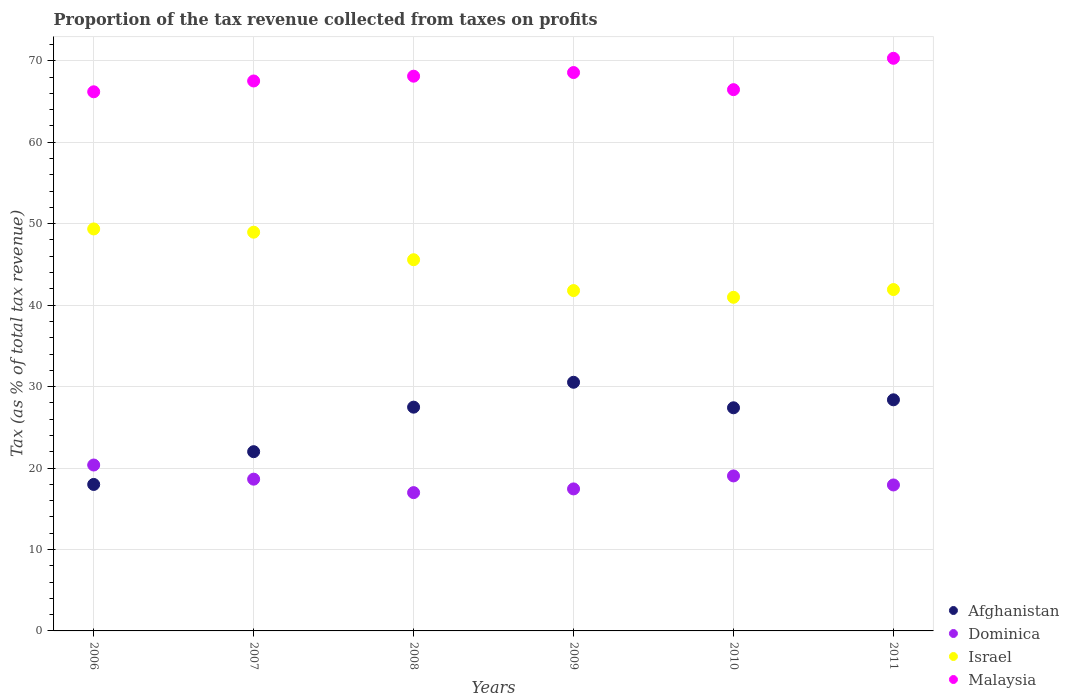How many different coloured dotlines are there?
Your answer should be very brief. 4. Is the number of dotlines equal to the number of legend labels?
Ensure brevity in your answer.  Yes. What is the proportion of the tax revenue collected in Dominica in 2007?
Your answer should be very brief. 18.63. Across all years, what is the maximum proportion of the tax revenue collected in Afghanistan?
Provide a short and direct response. 30.53. Across all years, what is the minimum proportion of the tax revenue collected in Afghanistan?
Offer a terse response. 17.98. In which year was the proportion of the tax revenue collected in Israel maximum?
Make the answer very short. 2006. In which year was the proportion of the tax revenue collected in Dominica minimum?
Make the answer very short. 2008. What is the total proportion of the tax revenue collected in Malaysia in the graph?
Provide a succinct answer. 407.17. What is the difference between the proportion of the tax revenue collected in Afghanistan in 2007 and that in 2008?
Keep it short and to the point. -5.47. What is the difference between the proportion of the tax revenue collected in Afghanistan in 2009 and the proportion of the tax revenue collected in Dominica in 2008?
Your response must be concise. 13.55. What is the average proportion of the tax revenue collected in Israel per year?
Offer a very short reply. 44.76. In the year 2008, what is the difference between the proportion of the tax revenue collected in Malaysia and proportion of the tax revenue collected in Israel?
Your answer should be very brief. 22.54. In how many years, is the proportion of the tax revenue collected in Afghanistan greater than 52 %?
Offer a very short reply. 0. What is the ratio of the proportion of the tax revenue collected in Afghanistan in 2008 to that in 2010?
Provide a short and direct response. 1. Is the proportion of the tax revenue collected in Afghanistan in 2006 less than that in 2010?
Keep it short and to the point. Yes. What is the difference between the highest and the second highest proportion of the tax revenue collected in Afghanistan?
Offer a terse response. 2.15. What is the difference between the highest and the lowest proportion of the tax revenue collected in Israel?
Your answer should be very brief. 8.39. In how many years, is the proportion of the tax revenue collected in Afghanistan greater than the average proportion of the tax revenue collected in Afghanistan taken over all years?
Offer a terse response. 4. Is the sum of the proportion of the tax revenue collected in Afghanistan in 2006 and 2010 greater than the maximum proportion of the tax revenue collected in Israel across all years?
Your response must be concise. No. Is it the case that in every year, the sum of the proportion of the tax revenue collected in Malaysia and proportion of the tax revenue collected in Afghanistan  is greater than the sum of proportion of the tax revenue collected in Dominica and proportion of the tax revenue collected in Israel?
Keep it short and to the point. No. Does the proportion of the tax revenue collected in Afghanistan monotonically increase over the years?
Give a very brief answer. No. Is the proportion of the tax revenue collected in Afghanistan strictly greater than the proportion of the tax revenue collected in Israel over the years?
Give a very brief answer. No. How many dotlines are there?
Make the answer very short. 4. Does the graph contain any zero values?
Make the answer very short. No. Where does the legend appear in the graph?
Your answer should be very brief. Bottom right. How many legend labels are there?
Offer a very short reply. 4. How are the legend labels stacked?
Ensure brevity in your answer.  Vertical. What is the title of the graph?
Ensure brevity in your answer.  Proportion of the tax revenue collected from taxes on profits. Does "South Asia" appear as one of the legend labels in the graph?
Your answer should be compact. No. What is the label or title of the Y-axis?
Your response must be concise. Tax (as % of total tax revenue). What is the Tax (as % of total tax revenue) of Afghanistan in 2006?
Ensure brevity in your answer.  17.98. What is the Tax (as % of total tax revenue) of Dominica in 2006?
Ensure brevity in your answer.  20.37. What is the Tax (as % of total tax revenue) of Israel in 2006?
Provide a short and direct response. 49.36. What is the Tax (as % of total tax revenue) of Malaysia in 2006?
Provide a short and direct response. 66.2. What is the Tax (as % of total tax revenue) in Afghanistan in 2007?
Provide a short and direct response. 22.01. What is the Tax (as % of total tax revenue) in Dominica in 2007?
Your response must be concise. 18.63. What is the Tax (as % of total tax revenue) in Israel in 2007?
Make the answer very short. 48.96. What is the Tax (as % of total tax revenue) in Malaysia in 2007?
Your response must be concise. 67.53. What is the Tax (as % of total tax revenue) in Afghanistan in 2008?
Provide a succinct answer. 27.48. What is the Tax (as % of total tax revenue) of Dominica in 2008?
Ensure brevity in your answer.  16.98. What is the Tax (as % of total tax revenue) of Israel in 2008?
Provide a succinct answer. 45.58. What is the Tax (as % of total tax revenue) in Malaysia in 2008?
Your response must be concise. 68.11. What is the Tax (as % of total tax revenue) of Afghanistan in 2009?
Your answer should be very brief. 30.53. What is the Tax (as % of total tax revenue) of Dominica in 2009?
Keep it short and to the point. 17.44. What is the Tax (as % of total tax revenue) in Israel in 2009?
Give a very brief answer. 41.79. What is the Tax (as % of total tax revenue) in Malaysia in 2009?
Give a very brief answer. 68.56. What is the Tax (as % of total tax revenue) in Afghanistan in 2010?
Provide a succinct answer. 27.4. What is the Tax (as % of total tax revenue) in Dominica in 2010?
Provide a short and direct response. 19.03. What is the Tax (as % of total tax revenue) of Israel in 2010?
Keep it short and to the point. 40.97. What is the Tax (as % of total tax revenue) in Malaysia in 2010?
Make the answer very short. 66.46. What is the Tax (as % of total tax revenue) of Afghanistan in 2011?
Make the answer very short. 28.38. What is the Tax (as % of total tax revenue) of Dominica in 2011?
Give a very brief answer. 17.92. What is the Tax (as % of total tax revenue) in Israel in 2011?
Give a very brief answer. 41.92. What is the Tax (as % of total tax revenue) of Malaysia in 2011?
Your answer should be compact. 70.31. Across all years, what is the maximum Tax (as % of total tax revenue) in Afghanistan?
Make the answer very short. 30.53. Across all years, what is the maximum Tax (as % of total tax revenue) of Dominica?
Ensure brevity in your answer.  20.37. Across all years, what is the maximum Tax (as % of total tax revenue) in Israel?
Your answer should be compact. 49.36. Across all years, what is the maximum Tax (as % of total tax revenue) in Malaysia?
Ensure brevity in your answer.  70.31. Across all years, what is the minimum Tax (as % of total tax revenue) in Afghanistan?
Provide a succinct answer. 17.98. Across all years, what is the minimum Tax (as % of total tax revenue) in Dominica?
Keep it short and to the point. 16.98. Across all years, what is the minimum Tax (as % of total tax revenue) in Israel?
Ensure brevity in your answer.  40.97. Across all years, what is the minimum Tax (as % of total tax revenue) of Malaysia?
Ensure brevity in your answer.  66.2. What is the total Tax (as % of total tax revenue) of Afghanistan in the graph?
Make the answer very short. 153.78. What is the total Tax (as % of total tax revenue) of Dominica in the graph?
Give a very brief answer. 110.37. What is the total Tax (as % of total tax revenue) of Israel in the graph?
Your response must be concise. 268.57. What is the total Tax (as % of total tax revenue) of Malaysia in the graph?
Ensure brevity in your answer.  407.17. What is the difference between the Tax (as % of total tax revenue) of Afghanistan in 2006 and that in 2007?
Your response must be concise. -4.02. What is the difference between the Tax (as % of total tax revenue) of Dominica in 2006 and that in 2007?
Your response must be concise. 1.74. What is the difference between the Tax (as % of total tax revenue) of Israel in 2006 and that in 2007?
Your answer should be very brief. 0.4. What is the difference between the Tax (as % of total tax revenue) of Malaysia in 2006 and that in 2007?
Provide a succinct answer. -1.33. What is the difference between the Tax (as % of total tax revenue) in Afghanistan in 2006 and that in 2008?
Provide a succinct answer. -9.49. What is the difference between the Tax (as % of total tax revenue) of Dominica in 2006 and that in 2008?
Offer a terse response. 3.39. What is the difference between the Tax (as % of total tax revenue) in Israel in 2006 and that in 2008?
Offer a very short reply. 3.78. What is the difference between the Tax (as % of total tax revenue) of Malaysia in 2006 and that in 2008?
Make the answer very short. -1.92. What is the difference between the Tax (as % of total tax revenue) in Afghanistan in 2006 and that in 2009?
Provide a short and direct response. -12.55. What is the difference between the Tax (as % of total tax revenue) in Dominica in 2006 and that in 2009?
Provide a succinct answer. 2.94. What is the difference between the Tax (as % of total tax revenue) of Israel in 2006 and that in 2009?
Your response must be concise. 7.57. What is the difference between the Tax (as % of total tax revenue) of Malaysia in 2006 and that in 2009?
Provide a succinct answer. -2.36. What is the difference between the Tax (as % of total tax revenue) of Afghanistan in 2006 and that in 2010?
Your answer should be very brief. -9.41. What is the difference between the Tax (as % of total tax revenue) in Dominica in 2006 and that in 2010?
Your response must be concise. 1.34. What is the difference between the Tax (as % of total tax revenue) of Israel in 2006 and that in 2010?
Your answer should be very brief. 8.39. What is the difference between the Tax (as % of total tax revenue) of Malaysia in 2006 and that in 2010?
Your answer should be compact. -0.26. What is the difference between the Tax (as % of total tax revenue) in Afghanistan in 2006 and that in 2011?
Provide a succinct answer. -10.39. What is the difference between the Tax (as % of total tax revenue) of Dominica in 2006 and that in 2011?
Your response must be concise. 2.45. What is the difference between the Tax (as % of total tax revenue) of Israel in 2006 and that in 2011?
Provide a short and direct response. 7.44. What is the difference between the Tax (as % of total tax revenue) of Malaysia in 2006 and that in 2011?
Provide a succinct answer. -4.11. What is the difference between the Tax (as % of total tax revenue) of Afghanistan in 2007 and that in 2008?
Your answer should be very brief. -5.47. What is the difference between the Tax (as % of total tax revenue) in Dominica in 2007 and that in 2008?
Offer a terse response. 1.65. What is the difference between the Tax (as % of total tax revenue) of Israel in 2007 and that in 2008?
Ensure brevity in your answer.  3.38. What is the difference between the Tax (as % of total tax revenue) of Malaysia in 2007 and that in 2008?
Provide a short and direct response. -0.59. What is the difference between the Tax (as % of total tax revenue) in Afghanistan in 2007 and that in 2009?
Ensure brevity in your answer.  -8.52. What is the difference between the Tax (as % of total tax revenue) in Dominica in 2007 and that in 2009?
Provide a short and direct response. 1.2. What is the difference between the Tax (as % of total tax revenue) in Israel in 2007 and that in 2009?
Your answer should be compact. 7.17. What is the difference between the Tax (as % of total tax revenue) in Malaysia in 2007 and that in 2009?
Offer a terse response. -1.04. What is the difference between the Tax (as % of total tax revenue) in Afghanistan in 2007 and that in 2010?
Make the answer very short. -5.39. What is the difference between the Tax (as % of total tax revenue) in Dominica in 2007 and that in 2010?
Offer a terse response. -0.4. What is the difference between the Tax (as % of total tax revenue) of Israel in 2007 and that in 2010?
Keep it short and to the point. 7.99. What is the difference between the Tax (as % of total tax revenue) of Malaysia in 2007 and that in 2010?
Your answer should be very brief. 1.07. What is the difference between the Tax (as % of total tax revenue) of Afghanistan in 2007 and that in 2011?
Offer a terse response. -6.37. What is the difference between the Tax (as % of total tax revenue) in Dominica in 2007 and that in 2011?
Give a very brief answer. 0.71. What is the difference between the Tax (as % of total tax revenue) in Israel in 2007 and that in 2011?
Your answer should be compact. 7.04. What is the difference between the Tax (as % of total tax revenue) in Malaysia in 2007 and that in 2011?
Provide a succinct answer. -2.79. What is the difference between the Tax (as % of total tax revenue) of Afghanistan in 2008 and that in 2009?
Offer a terse response. -3.06. What is the difference between the Tax (as % of total tax revenue) in Dominica in 2008 and that in 2009?
Your answer should be very brief. -0.45. What is the difference between the Tax (as % of total tax revenue) of Israel in 2008 and that in 2009?
Make the answer very short. 3.79. What is the difference between the Tax (as % of total tax revenue) of Malaysia in 2008 and that in 2009?
Offer a very short reply. -0.45. What is the difference between the Tax (as % of total tax revenue) in Afghanistan in 2008 and that in 2010?
Provide a succinct answer. 0.08. What is the difference between the Tax (as % of total tax revenue) of Dominica in 2008 and that in 2010?
Provide a short and direct response. -2.05. What is the difference between the Tax (as % of total tax revenue) in Israel in 2008 and that in 2010?
Offer a terse response. 4.61. What is the difference between the Tax (as % of total tax revenue) of Malaysia in 2008 and that in 2010?
Provide a succinct answer. 1.65. What is the difference between the Tax (as % of total tax revenue) in Afghanistan in 2008 and that in 2011?
Ensure brevity in your answer.  -0.9. What is the difference between the Tax (as % of total tax revenue) in Dominica in 2008 and that in 2011?
Your response must be concise. -0.94. What is the difference between the Tax (as % of total tax revenue) of Israel in 2008 and that in 2011?
Your response must be concise. 3.66. What is the difference between the Tax (as % of total tax revenue) in Malaysia in 2008 and that in 2011?
Give a very brief answer. -2.2. What is the difference between the Tax (as % of total tax revenue) of Afghanistan in 2009 and that in 2010?
Provide a succinct answer. 3.13. What is the difference between the Tax (as % of total tax revenue) in Dominica in 2009 and that in 2010?
Provide a succinct answer. -1.59. What is the difference between the Tax (as % of total tax revenue) in Israel in 2009 and that in 2010?
Keep it short and to the point. 0.82. What is the difference between the Tax (as % of total tax revenue) in Malaysia in 2009 and that in 2010?
Your answer should be compact. 2.1. What is the difference between the Tax (as % of total tax revenue) of Afghanistan in 2009 and that in 2011?
Your answer should be very brief. 2.15. What is the difference between the Tax (as % of total tax revenue) of Dominica in 2009 and that in 2011?
Your answer should be compact. -0.49. What is the difference between the Tax (as % of total tax revenue) in Israel in 2009 and that in 2011?
Your answer should be compact. -0.13. What is the difference between the Tax (as % of total tax revenue) in Malaysia in 2009 and that in 2011?
Make the answer very short. -1.75. What is the difference between the Tax (as % of total tax revenue) in Afghanistan in 2010 and that in 2011?
Offer a very short reply. -0.98. What is the difference between the Tax (as % of total tax revenue) of Dominica in 2010 and that in 2011?
Your answer should be compact. 1.11. What is the difference between the Tax (as % of total tax revenue) in Israel in 2010 and that in 2011?
Your answer should be compact. -0.95. What is the difference between the Tax (as % of total tax revenue) in Malaysia in 2010 and that in 2011?
Provide a succinct answer. -3.85. What is the difference between the Tax (as % of total tax revenue) of Afghanistan in 2006 and the Tax (as % of total tax revenue) of Dominica in 2007?
Give a very brief answer. -0.65. What is the difference between the Tax (as % of total tax revenue) in Afghanistan in 2006 and the Tax (as % of total tax revenue) in Israel in 2007?
Keep it short and to the point. -30.97. What is the difference between the Tax (as % of total tax revenue) of Afghanistan in 2006 and the Tax (as % of total tax revenue) of Malaysia in 2007?
Make the answer very short. -49.54. What is the difference between the Tax (as % of total tax revenue) of Dominica in 2006 and the Tax (as % of total tax revenue) of Israel in 2007?
Offer a very short reply. -28.59. What is the difference between the Tax (as % of total tax revenue) of Dominica in 2006 and the Tax (as % of total tax revenue) of Malaysia in 2007?
Provide a succinct answer. -47.15. What is the difference between the Tax (as % of total tax revenue) of Israel in 2006 and the Tax (as % of total tax revenue) of Malaysia in 2007?
Offer a very short reply. -18.17. What is the difference between the Tax (as % of total tax revenue) of Afghanistan in 2006 and the Tax (as % of total tax revenue) of Israel in 2008?
Ensure brevity in your answer.  -27.59. What is the difference between the Tax (as % of total tax revenue) of Afghanistan in 2006 and the Tax (as % of total tax revenue) of Malaysia in 2008?
Keep it short and to the point. -50.13. What is the difference between the Tax (as % of total tax revenue) in Dominica in 2006 and the Tax (as % of total tax revenue) in Israel in 2008?
Offer a very short reply. -25.21. What is the difference between the Tax (as % of total tax revenue) of Dominica in 2006 and the Tax (as % of total tax revenue) of Malaysia in 2008?
Provide a short and direct response. -47.74. What is the difference between the Tax (as % of total tax revenue) of Israel in 2006 and the Tax (as % of total tax revenue) of Malaysia in 2008?
Provide a succinct answer. -18.76. What is the difference between the Tax (as % of total tax revenue) in Afghanistan in 2006 and the Tax (as % of total tax revenue) in Dominica in 2009?
Ensure brevity in your answer.  0.55. What is the difference between the Tax (as % of total tax revenue) in Afghanistan in 2006 and the Tax (as % of total tax revenue) in Israel in 2009?
Make the answer very short. -23.81. What is the difference between the Tax (as % of total tax revenue) in Afghanistan in 2006 and the Tax (as % of total tax revenue) in Malaysia in 2009?
Your answer should be very brief. -50.58. What is the difference between the Tax (as % of total tax revenue) in Dominica in 2006 and the Tax (as % of total tax revenue) in Israel in 2009?
Your answer should be compact. -21.42. What is the difference between the Tax (as % of total tax revenue) of Dominica in 2006 and the Tax (as % of total tax revenue) of Malaysia in 2009?
Give a very brief answer. -48.19. What is the difference between the Tax (as % of total tax revenue) of Israel in 2006 and the Tax (as % of total tax revenue) of Malaysia in 2009?
Give a very brief answer. -19.2. What is the difference between the Tax (as % of total tax revenue) of Afghanistan in 2006 and the Tax (as % of total tax revenue) of Dominica in 2010?
Your response must be concise. -1.05. What is the difference between the Tax (as % of total tax revenue) in Afghanistan in 2006 and the Tax (as % of total tax revenue) in Israel in 2010?
Your answer should be very brief. -22.98. What is the difference between the Tax (as % of total tax revenue) in Afghanistan in 2006 and the Tax (as % of total tax revenue) in Malaysia in 2010?
Make the answer very short. -48.48. What is the difference between the Tax (as % of total tax revenue) of Dominica in 2006 and the Tax (as % of total tax revenue) of Israel in 2010?
Ensure brevity in your answer.  -20.59. What is the difference between the Tax (as % of total tax revenue) in Dominica in 2006 and the Tax (as % of total tax revenue) in Malaysia in 2010?
Keep it short and to the point. -46.09. What is the difference between the Tax (as % of total tax revenue) of Israel in 2006 and the Tax (as % of total tax revenue) of Malaysia in 2010?
Your response must be concise. -17.1. What is the difference between the Tax (as % of total tax revenue) of Afghanistan in 2006 and the Tax (as % of total tax revenue) of Dominica in 2011?
Your response must be concise. 0.06. What is the difference between the Tax (as % of total tax revenue) of Afghanistan in 2006 and the Tax (as % of total tax revenue) of Israel in 2011?
Provide a short and direct response. -23.93. What is the difference between the Tax (as % of total tax revenue) in Afghanistan in 2006 and the Tax (as % of total tax revenue) in Malaysia in 2011?
Keep it short and to the point. -52.33. What is the difference between the Tax (as % of total tax revenue) of Dominica in 2006 and the Tax (as % of total tax revenue) of Israel in 2011?
Ensure brevity in your answer.  -21.55. What is the difference between the Tax (as % of total tax revenue) of Dominica in 2006 and the Tax (as % of total tax revenue) of Malaysia in 2011?
Your answer should be compact. -49.94. What is the difference between the Tax (as % of total tax revenue) in Israel in 2006 and the Tax (as % of total tax revenue) in Malaysia in 2011?
Provide a succinct answer. -20.95. What is the difference between the Tax (as % of total tax revenue) of Afghanistan in 2007 and the Tax (as % of total tax revenue) of Dominica in 2008?
Give a very brief answer. 5.03. What is the difference between the Tax (as % of total tax revenue) in Afghanistan in 2007 and the Tax (as % of total tax revenue) in Israel in 2008?
Your answer should be very brief. -23.57. What is the difference between the Tax (as % of total tax revenue) of Afghanistan in 2007 and the Tax (as % of total tax revenue) of Malaysia in 2008?
Your response must be concise. -46.1. What is the difference between the Tax (as % of total tax revenue) of Dominica in 2007 and the Tax (as % of total tax revenue) of Israel in 2008?
Provide a short and direct response. -26.94. What is the difference between the Tax (as % of total tax revenue) in Dominica in 2007 and the Tax (as % of total tax revenue) in Malaysia in 2008?
Offer a very short reply. -49.48. What is the difference between the Tax (as % of total tax revenue) of Israel in 2007 and the Tax (as % of total tax revenue) of Malaysia in 2008?
Provide a succinct answer. -19.16. What is the difference between the Tax (as % of total tax revenue) in Afghanistan in 2007 and the Tax (as % of total tax revenue) in Dominica in 2009?
Give a very brief answer. 4.57. What is the difference between the Tax (as % of total tax revenue) in Afghanistan in 2007 and the Tax (as % of total tax revenue) in Israel in 2009?
Keep it short and to the point. -19.78. What is the difference between the Tax (as % of total tax revenue) of Afghanistan in 2007 and the Tax (as % of total tax revenue) of Malaysia in 2009?
Make the answer very short. -46.55. What is the difference between the Tax (as % of total tax revenue) of Dominica in 2007 and the Tax (as % of total tax revenue) of Israel in 2009?
Provide a short and direct response. -23.16. What is the difference between the Tax (as % of total tax revenue) in Dominica in 2007 and the Tax (as % of total tax revenue) in Malaysia in 2009?
Give a very brief answer. -49.93. What is the difference between the Tax (as % of total tax revenue) of Israel in 2007 and the Tax (as % of total tax revenue) of Malaysia in 2009?
Give a very brief answer. -19.6. What is the difference between the Tax (as % of total tax revenue) in Afghanistan in 2007 and the Tax (as % of total tax revenue) in Dominica in 2010?
Ensure brevity in your answer.  2.98. What is the difference between the Tax (as % of total tax revenue) of Afghanistan in 2007 and the Tax (as % of total tax revenue) of Israel in 2010?
Give a very brief answer. -18.96. What is the difference between the Tax (as % of total tax revenue) in Afghanistan in 2007 and the Tax (as % of total tax revenue) in Malaysia in 2010?
Provide a short and direct response. -44.45. What is the difference between the Tax (as % of total tax revenue) in Dominica in 2007 and the Tax (as % of total tax revenue) in Israel in 2010?
Ensure brevity in your answer.  -22.33. What is the difference between the Tax (as % of total tax revenue) in Dominica in 2007 and the Tax (as % of total tax revenue) in Malaysia in 2010?
Your answer should be compact. -47.83. What is the difference between the Tax (as % of total tax revenue) in Israel in 2007 and the Tax (as % of total tax revenue) in Malaysia in 2010?
Your response must be concise. -17.5. What is the difference between the Tax (as % of total tax revenue) of Afghanistan in 2007 and the Tax (as % of total tax revenue) of Dominica in 2011?
Provide a succinct answer. 4.09. What is the difference between the Tax (as % of total tax revenue) of Afghanistan in 2007 and the Tax (as % of total tax revenue) of Israel in 2011?
Offer a very short reply. -19.91. What is the difference between the Tax (as % of total tax revenue) in Afghanistan in 2007 and the Tax (as % of total tax revenue) in Malaysia in 2011?
Offer a terse response. -48.3. What is the difference between the Tax (as % of total tax revenue) in Dominica in 2007 and the Tax (as % of total tax revenue) in Israel in 2011?
Provide a short and direct response. -23.28. What is the difference between the Tax (as % of total tax revenue) of Dominica in 2007 and the Tax (as % of total tax revenue) of Malaysia in 2011?
Make the answer very short. -51.68. What is the difference between the Tax (as % of total tax revenue) of Israel in 2007 and the Tax (as % of total tax revenue) of Malaysia in 2011?
Offer a very short reply. -21.35. What is the difference between the Tax (as % of total tax revenue) of Afghanistan in 2008 and the Tax (as % of total tax revenue) of Dominica in 2009?
Your response must be concise. 10.04. What is the difference between the Tax (as % of total tax revenue) in Afghanistan in 2008 and the Tax (as % of total tax revenue) in Israel in 2009?
Give a very brief answer. -14.32. What is the difference between the Tax (as % of total tax revenue) of Afghanistan in 2008 and the Tax (as % of total tax revenue) of Malaysia in 2009?
Keep it short and to the point. -41.09. What is the difference between the Tax (as % of total tax revenue) of Dominica in 2008 and the Tax (as % of total tax revenue) of Israel in 2009?
Your answer should be very brief. -24.81. What is the difference between the Tax (as % of total tax revenue) in Dominica in 2008 and the Tax (as % of total tax revenue) in Malaysia in 2009?
Your answer should be very brief. -51.58. What is the difference between the Tax (as % of total tax revenue) in Israel in 2008 and the Tax (as % of total tax revenue) in Malaysia in 2009?
Your response must be concise. -22.98. What is the difference between the Tax (as % of total tax revenue) in Afghanistan in 2008 and the Tax (as % of total tax revenue) in Dominica in 2010?
Ensure brevity in your answer.  8.44. What is the difference between the Tax (as % of total tax revenue) of Afghanistan in 2008 and the Tax (as % of total tax revenue) of Israel in 2010?
Make the answer very short. -13.49. What is the difference between the Tax (as % of total tax revenue) of Afghanistan in 2008 and the Tax (as % of total tax revenue) of Malaysia in 2010?
Provide a succinct answer. -38.98. What is the difference between the Tax (as % of total tax revenue) of Dominica in 2008 and the Tax (as % of total tax revenue) of Israel in 2010?
Give a very brief answer. -23.98. What is the difference between the Tax (as % of total tax revenue) in Dominica in 2008 and the Tax (as % of total tax revenue) in Malaysia in 2010?
Keep it short and to the point. -49.48. What is the difference between the Tax (as % of total tax revenue) of Israel in 2008 and the Tax (as % of total tax revenue) of Malaysia in 2010?
Your answer should be very brief. -20.88. What is the difference between the Tax (as % of total tax revenue) in Afghanistan in 2008 and the Tax (as % of total tax revenue) in Dominica in 2011?
Make the answer very short. 9.55. What is the difference between the Tax (as % of total tax revenue) of Afghanistan in 2008 and the Tax (as % of total tax revenue) of Israel in 2011?
Provide a short and direct response. -14.44. What is the difference between the Tax (as % of total tax revenue) of Afghanistan in 2008 and the Tax (as % of total tax revenue) of Malaysia in 2011?
Provide a succinct answer. -42.84. What is the difference between the Tax (as % of total tax revenue) in Dominica in 2008 and the Tax (as % of total tax revenue) in Israel in 2011?
Offer a very short reply. -24.94. What is the difference between the Tax (as % of total tax revenue) of Dominica in 2008 and the Tax (as % of total tax revenue) of Malaysia in 2011?
Keep it short and to the point. -53.33. What is the difference between the Tax (as % of total tax revenue) in Israel in 2008 and the Tax (as % of total tax revenue) in Malaysia in 2011?
Provide a short and direct response. -24.73. What is the difference between the Tax (as % of total tax revenue) of Afghanistan in 2009 and the Tax (as % of total tax revenue) of Dominica in 2010?
Offer a very short reply. 11.5. What is the difference between the Tax (as % of total tax revenue) of Afghanistan in 2009 and the Tax (as % of total tax revenue) of Israel in 2010?
Provide a short and direct response. -10.43. What is the difference between the Tax (as % of total tax revenue) in Afghanistan in 2009 and the Tax (as % of total tax revenue) in Malaysia in 2010?
Provide a succinct answer. -35.93. What is the difference between the Tax (as % of total tax revenue) in Dominica in 2009 and the Tax (as % of total tax revenue) in Israel in 2010?
Your answer should be very brief. -23.53. What is the difference between the Tax (as % of total tax revenue) of Dominica in 2009 and the Tax (as % of total tax revenue) of Malaysia in 2010?
Give a very brief answer. -49.02. What is the difference between the Tax (as % of total tax revenue) in Israel in 2009 and the Tax (as % of total tax revenue) in Malaysia in 2010?
Give a very brief answer. -24.67. What is the difference between the Tax (as % of total tax revenue) of Afghanistan in 2009 and the Tax (as % of total tax revenue) of Dominica in 2011?
Make the answer very short. 12.61. What is the difference between the Tax (as % of total tax revenue) of Afghanistan in 2009 and the Tax (as % of total tax revenue) of Israel in 2011?
Give a very brief answer. -11.39. What is the difference between the Tax (as % of total tax revenue) in Afghanistan in 2009 and the Tax (as % of total tax revenue) in Malaysia in 2011?
Your answer should be very brief. -39.78. What is the difference between the Tax (as % of total tax revenue) in Dominica in 2009 and the Tax (as % of total tax revenue) in Israel in 2011?
Ensure brevity in your answer.  -24.48. What is the difference between the Tax (as % of total tax revenue) in Dominica in 2009 and the Tax (as % of total tax revenue) in Malaysia in 2011?
Give a very brief answer. -52.87. What is the difference between the Tax (as % of total tax revenue) in Israel in 2009 and the Tax (as % of total tax revenue) in Malaysia in 2011?
Your answer should be very brief. -28.52. What is the difference between the Tax (as % of total tax revenue) in Afghanistan in 2010 and the Tax (as % of total tax revenue) in Dominica in 2011?
Your response must be concise. 9.48. What is the difference between the Tax (as % of total tax revenue) of Afghanistan in 2010 and the Tax (as % of total tax revenue) of Israel in 2011?
Offer a terse response. -14.52. What is the difference between the Tax (as % of total tax revenue) in Afghanistan in 2010 and the Tax (as % of total tax revenue) in Malaysia in 2011?
Offer a very short reply. -42.91. What is the difference between the Tax (as % of total tax revenue) in Dominica in 2010 and the Tax (as % of total tax revenue) in Israel in 2011?
Your response must be concise. -22.89. What is the difference between the Tax (as % of total tax revenue) of Dominica in 2010 and the Tax (as % of total tax revenue) of Malaysia in 2011?
Your response must be concise. -51.28. What is the difference between the Tax (as % of total tax revenue) in Israel in 2010 and the Tax (as % of total tax revenue) in Malaysia in 2011?
Give a very brief answer. -29.35. What is the average Tax (as % of total tax revenue) of Afghanistan per year?
Give a very brief answer. 25.63. What is the average Tax (as % of total tax revenue) in Dominica per year?
Ensure brevity in your answer.  18.4. What is the average Tax (as % of total tax revenue) of Israel per year?
Ensure brevity in your answer.  44.76. What is the average Tax (as % of total tax revenue) of Malaysia per year?
Your answer should be very brief. 67.86. In the year 2006, what is the difference between the Tax (as % of total tax revenue) in Afghanistan and Tax (as % of total tax revenue) in Dominica?
Your answer should be very brief. -2.39. In the year 2006, what is the difference between the Tax (as % of total tax revenue) of Afghanistan and Tax (as % of total tax revenue) of Israel?
Your response must be concise. -31.37. In the year 2006, what is the difference between the Tax (as % of total tax revenue) in Afghanistan and Tax (as % of total tax revenue) in Malaysia?
Offer a very short reply. -48.21. In the year 2006, what is the difference between the Tax (as % of total tax revenue) of Dominica and Tax (as % of total tax revenue) of Israel?
Give a very brief answer. -28.99. In the year 2006, what is the difference between the Tax (as % of total tax revenue) of Dominica and Tax (as % of total tax revenue) of Malaysia?
Keep it short and to the point. -45.83. In the year 2006, what is the difference between the Tax (as % of total tax revenue) in Israel and Tax (as % of total tax revenue) in Malaysia?
Your answer should be compact. -16.84. In the year 2007, what is the difference between the Tax (as % of total tax revenue) of Afghanistan and Tax (as % of total tax revenue) of Dominica?
Offer a very short reply. 3.37. In the year 2007, what is the difference between the Tax (as % of total tax revenue) of Afghanistan and Tax (as % of total tax revenue) of Israel?
Your response must be concise. -26.95. In the year 2007, what is the difference between the Tax (as % of total tax revenue) of Afghanistan and Tax (as % of total tax revenue) of Malaysia?
Keep it short and to the point. -45.52. In the year 2007, what is the difference between the Tax (as % of total tax revenue) of Dominica and Tax (as % of total tax revenue) of Israel?
Your answer should be compact. -30.32. In the year 2007, what is the difference between the Tax (as % of total tax revenue) in Dominica and Tax (as % of total tax revenue) in Malaysia?
Offer a very short reply. -48.89. In the year 2007, what is the difference between the Tax (as % of total tax revenue) of Israel and Tax (as % of total tax revenue) of Malaysia?
Your answer should be very brief. -18.57. In the year 2008, what is the difference between the Tax (as % of total tax revenue) in Afghanistan and Tax (as % of total tax revenue) in Dominica?
Make the answer very short. 10.49. In the year 2008, what is the difference between the Tax (as % of total tax revenue) in Afghanistan and Tax (as % of total tax revenue) in Israel?
Provide a short and direct response. -18.1. In the year 2008, what is the difference between the Tax (as % of total tax revenue) of Afghanistan and Tax (as % of total tax revenue) of Malaysia?
Provide a succinct answer. -40.64. In the year 2008, what is the difference between the Tax (as % of total tax revenue) in Dominica and Tax (as % of total tax revenue) in Israel?
Offer a terse response. -28.6. In the year 2008, what is the difference between the Tax (as % of total tax revenue) of Dominica and Tax (as % of total tax revenue) of Malaysia?
Keep it short and to the point. -51.13. In the year 2008, what is the difference between the Tax (as % of total tax revenue) of Israel and Tax (as % of total tax revenue) of Malaysia?
Provide a succinct answer. -22.54. In the year 2009, what is the difference between the Tax (as % of total tax revenue) in Afghanistan and Tax (as % of total tax revenue) in Dominica?
Your answer should be very brief. 13.1. In the year 2009, what is the difference between the Tax (as % of total tax revenue) of Afghanistan and Tax (as % of total tax revenue) of Israel?
Your response must be concise. -11.26. In the year 2009, what is the difference between the Tax (as % of total tax revenue) of Afghanistan and Tax (as % of total tax revenue) of Malaysia?
Your response must be concise. -38.03. In the year 2009, what is the difference between the Tax (as % of total tax revenue) in Dominica and Tax (as % of total tax revenue) in Israel?
Provide a succinct answer. -24.35. In the year 2009, what is the difference between the Tax (as % of total tax revenue) of Dominica and Tax (as % of total tax revenue) of Malaysia?
Provide a short and direct response. -51.13. In the year 2009, what is the difference between the Tax (as % of total tax revenue) of Israel and Tax (as % of total tax revenue) of Malaysia?
Provide a succinct answer. -26.77. In the year 2010, what is the difference between the Tax (as % of total tax revenue) in Afghanistan and Tax (as % of total tax revenue) in Dominica?
Keep it short and to the point. 8.37. In the year 2010, what is the difference between the Tax (as % of total tax revenue) in Afghanistan and Tax (as % of total tax revenue) in Israel?
Keep it short and to the point. -13.57. In the year 2010, what is the difference between the Tax (as % of total tax revenue) in Afghanistan and Tax (as % of total tax revenue) in Malaysia?
Make the answer very short. -39.06. In the year 2010, what is the difference between the Tax (as % of total tax revenue) of Dominica and Tax (as % of total tax revenue) of Israel?
Your response must be concise. -21.94. In the year 2010, what is the difference between the Tax (as % of total tax revenue) in Dominica and Tax (as % of total tax revenue) in Malaysia?
Provide a succinct answer. -47.43. In the year 2010, what is the difference between the Tax (as % of total tax revenue) of Israel and Tax (as % of total tax revenue) of Malaysia?
Your response must be concise. -25.49. In the year 2011, what is the difference between the Tax (as % of total tax revenue) in Afghanistan and Tax (as % of total tax revenue) in Dominica?
Provide a succinct answer. 10.46. In the year 2011, what is the difference between the Tax (as % of total tax revenue) of Afghanistan and Tax (as % of total tax revenue) of Israel?
Ensure brevity in your answer.  -13.54. In the year 2011, what is the difference between the Tax (as % of total tax revenue) in Afghanistan and Tax (as % of total tax revenue) in Malaysia?
Your answer should be compact. -41.93. In the year 2011, what is the difference between the Tax (as % of total tax revenue) of Dominica and Tax (as % of total tax revenue) of Israel?
Your answer should be very brief. -23.99. In the year 2011, what is the difference between the Tax (as % of total tax revenue) of Dominica and Tax (as % of total tax revenue) of Malaysia?
Ensure brevity in your answer.  -52.39. In the year 2011, what is the difference between the Tax (as % of total tax revenue) of Israel and Tax (as % of total tax revenue) of Malaysia?
Offer a very short reply. -28.39. What is the ratio of the Tax (as % of total tax revenue) in Afghanistan in 2006 to that in 2007?
Provide a short and direct response. 0.82. What is the ratio of the Tax (as % of total tax revenue) in Dominica in 2006 to that in 2007?
Provide a succinct answer. 1.09. What is the ratio of the Tax (as % of total tax revenue) of Israel in 2006 to that in 2007?
Provide a short and direct response. 1.01. What is the ratio of the Tax (as % of total tax revenue) of Malaysia in 2006 to that in 2007?
Your answer should be compact. 0.98. What is the ratio of the Tax (as % of total tax revenue) in Afghanistan in 2006 to that in 2008?
Provide a succinct answer. 0.65. What is the ratio of the Tax (as % of total tax revenue) in Dominica in 2006 to that in 2008?
Offer a very short reply. 1.2. What is the ratio of the Tax (as % of total tax revenue) in Israel in 2006 to that in 2008?
Give a very brief answer. 1.08. What is the ratio of the Tax (as % of total tax revenue) in Malaysia in 2006 to that in 2008?
Offer a terse response. 0.97. What is the ratio of the Tax (as % of total tax revenue) of Afghanistan in 2006 to that in 2009?
Offer a terse response. 0.59. What is the ratio of the Tax (as % of total tax revenue) of Dominica in 2006 to that in 2009?
Your answer should be very brief. 1.17. What is the ratio of the Tax (as % of total tax revenue) of Israel in 2006 to that in 2009?
Your answer should be compact. 1.18. What is the ratio of the Tax (as % of total tax revenue) of Malaysia in 2006 to that in 2009?
Your response must be concise. 0.97. What is the ratio of the Tax (as % of total tax revenue) of Afghanistan in 2006 to that in 2010?
Keep it short and to the point. 0.66. What is the ratio of the Tax (as % of total tax revenue) of Dominica in 2006 to that in 2010?
Your answer should be very brief. 1.07. What is the ratio of the Tax (as % of total tax revenue) in Israel in 2006 to that in 2010?
Provide a succinct answer. 1.2. What is the ratio of the Tax (as % of total tax revenue) in Malaysia in 2006 to that in 2010?
Provide a short and direct response. 1. What is the ratio of the Tax (as % of total tax revenue) in Afghanistan in 2006 to that in 2011?
Offer a very short reply. 0.63. What is the ratio of the Tax (as % of total tax revenue) of Dominica in 2006 to that in 2011?
Ensure brevity in your answer.  1.14. What is the ratio of the Tax (as % of total tax revenue) in Israel in 2006 to that in 2011?
Your answer should be very brief. 1.18. What is the ratio of the Tax (as % of total tax revenue) of Malaysia in 2006 to that in 2011?
Make the answer very short. 0.94. What is the ratio of the Tax (as % of total tax revenue) in Afghanistan in 2007 to that in 2008?
Provide a short and direct response. 0.8. What is the ratio of the Tax (as % of total tax revenue) in Dominica in 2007 to that in 2008?
Provide a succinct answer. 1.1. What is the ratio of the Tax (as % of total tax revenue) in Israel in 2007 to that in 2008?
Your answer should be very brief. 1.07. What is the ratio of the Tax (as % of total tax revenue) in Malaysia in 2007 to that in 2008?
Offer a very short reply. 0.99. What is the ratio of the Tax (as % of total tax revenue) of Afghanistan in 2007 to that in 2009?
Ensure brevity in your answer.  0.72. What is the ratio of the Tax (as % of total tax revenue) of Dominica in 2007 to that in 2009?
Provide a short and direct response. 1.07. What is the ratio of the Tax (as % of total tax revenue) of Israel in 2007 to that in 2009?
Provide a succinct answer. 1.17. What is the ratio of the Tax (as % of total tax revenue) of Malaysia in 2007 to that in 2009?
Offer a terse response. 0.98. What is the ratio of the Tax (as % of total tax revenue) in Afghanistan in 2007 to that in 2010?
Provide a succinct answer. 0.8. What is the ratio of the Tax (as % of total tax revenue) of Dominica in 2007 to that in 2010?
Give a very brief answer. 0.98. What is the ratio of the Tax (as % of total tax revenue) of Israel in 2007 to that in 2010?
Provide a succinct answer. 1.2. What is the ratio of the Tax (as % of total tax revenue) of Afghanistan in 2007 to that in 2011?
Your response must be concise. 0.78. What is the ratio of the Tax (as % of total tax revenue) of Dominica in 2007 to that in 2011?
Make the answer very short. 1.04. What is the ratio of the Tax (as % of total tax revenue) in Israel in 2007 to that in 2011?
Your response must be concise. 1.17. What is the ratio of the Tax (as % of total tax revenue) in Malaysia in 2007 to that in 2011?
Your response must be concise. 0.96. What is the ratio of the Tax (as % of total tax revenue) of Afghanistan in 2008 to that in 2009?
Provide a short and direct response. 0.9. What is the ratio of the Tax (as % of total tax revenue) of Dominica in 2008 to that in 2009?
Give a very brief answer. 0.97. What is the ratio of the Tax (as % of total tax revenue) of Israel in 2008 to that in 2009?
Ensure brevity in your answer.  1.09. What is the ratio of the Tax (as % of total tax revenue) in Afghanistan in 2008 to that in 2010?
Offer a very short reply. 1. What is the ratio of the Tax (as % of total tax revenue) of Dominica in 2008 to that in 2010?
Provide a succinct answer. 0.89. What is the ratio of the Tax (as % of total tax revenue) in Israel in 2008 to that in 2010?
Ensure brevity in your answer.  1.11. What is the ratio of the Tax (as % of total tax revenue) in Malaysia in 2008 to that in 2010?
Give a very brief answer. 1.02. What is the ratio of the Tax (as % of total tax revenue) in Afghanistan in 2008 to that in 2011?
Provide a succinct answer. 0.97. What is the ratio of the Tax (as % of total tax revenue) in Dominica in 2008 to that in 2011?
Your answer should be compact. 0.95. What is the ratio of the Tax (as % of total tax revenue) of Israel in 2008 to that in 2011?
Make the answer very short. 1.09. What is the ratio of the Tax (as % of total tax revenue) in Malaysia in 2008 to that in 2011?
Keep it short and to the point. 0.97. What is the ratio of the Tax (as % of total tax revenue) in Afghanistan in 2009 to that in 2010?
Provide a succinct answer. 1.11. What is the ratio of the Tax (as % of total tax revenue) in Dominica in 2009 to that in 2010?
Give a very brief answer. 0.92. What is the ratio of the Tax (as % of total tax revenue) of Israel in 2009 to that in 2010?
Offer a very short reply. 1.02. What is the ratio of the Tax (as % of total tax revenue) of Malaysia in 2009 to that in 2010?
Your answer should be very brief. 1.03. What is the ratio of the Tax (as % of total tax revenue) in Afghanistan in 2009 to that in 2011?
Your response must be concise. 1.08. What is the ratio of the Tax (as % of total tax revenue) in Dominica in 2009 to that in 2011?
Provide a succinct answer. 0.97. What is the ratio of the Tax (as % of total tax revenue) in Israel in 2009 to that in 2011?
Your answer should be very brief. 1. What is the ratio of the Tax (as % of total tax revenue) of Malaysia in 2009 to that in 2011?
Offer a terse response. 0.98. What is the ratio of the Tax (as % of total tax revenue) of Afghanistan in 2010 to that in 2011?
Ensure brevity in your answer.  0.97. What is the ratio of the Tax (as % of total tax revenue) of Dominica in 2010 to that in 2011?
Offer a very short reply. 1.06. What is the ratio of the Tax (as % of total tax revenue) of Israel in 2010 to that in 2011?
Provide a succinct answer. 0.98. What is the ratio of the Tax (as % of total tax revenue) of Malaysia in 2010 to that in 2011?
Offer a terse response. 0.95. What is the difference between the highest and the second highest Tax (as % of total tax revenue) in Afghanistan?
Keep it short and to the point. 2.15. What is the difference between the highest and the second highest Tax (as % of total tax revenue) in Dominica?
Your answer should be very brief. 1.34. What is the difference between the highest and the second highest Tax (as % of total tax revenue) in Israel?
Keep it short and to the point. 0.4. What is the difference between the highest and the second highest Tax (as % of total tax revenue) of Malaysia?
Provide a succinct answer. 1.75. What is the difference between the highest and the lowest Tax (as % of total tax revenue) of Afghanistan?
Your answer should be compact. 12.55. What is the difference between the highest and the lowest Tax (as % of total tax revenue) of Dominica?
Offer a terse response. 3.39. What is the difference between the highest and the lowest Tax (as % of total tax revenue) in Israel?
Give a very brief answer. 8.39. What is the difference between the highest and the lowest Tax (as % of total tax revenue) of Malaysia?
Your answer should be very brief. 4.11. 